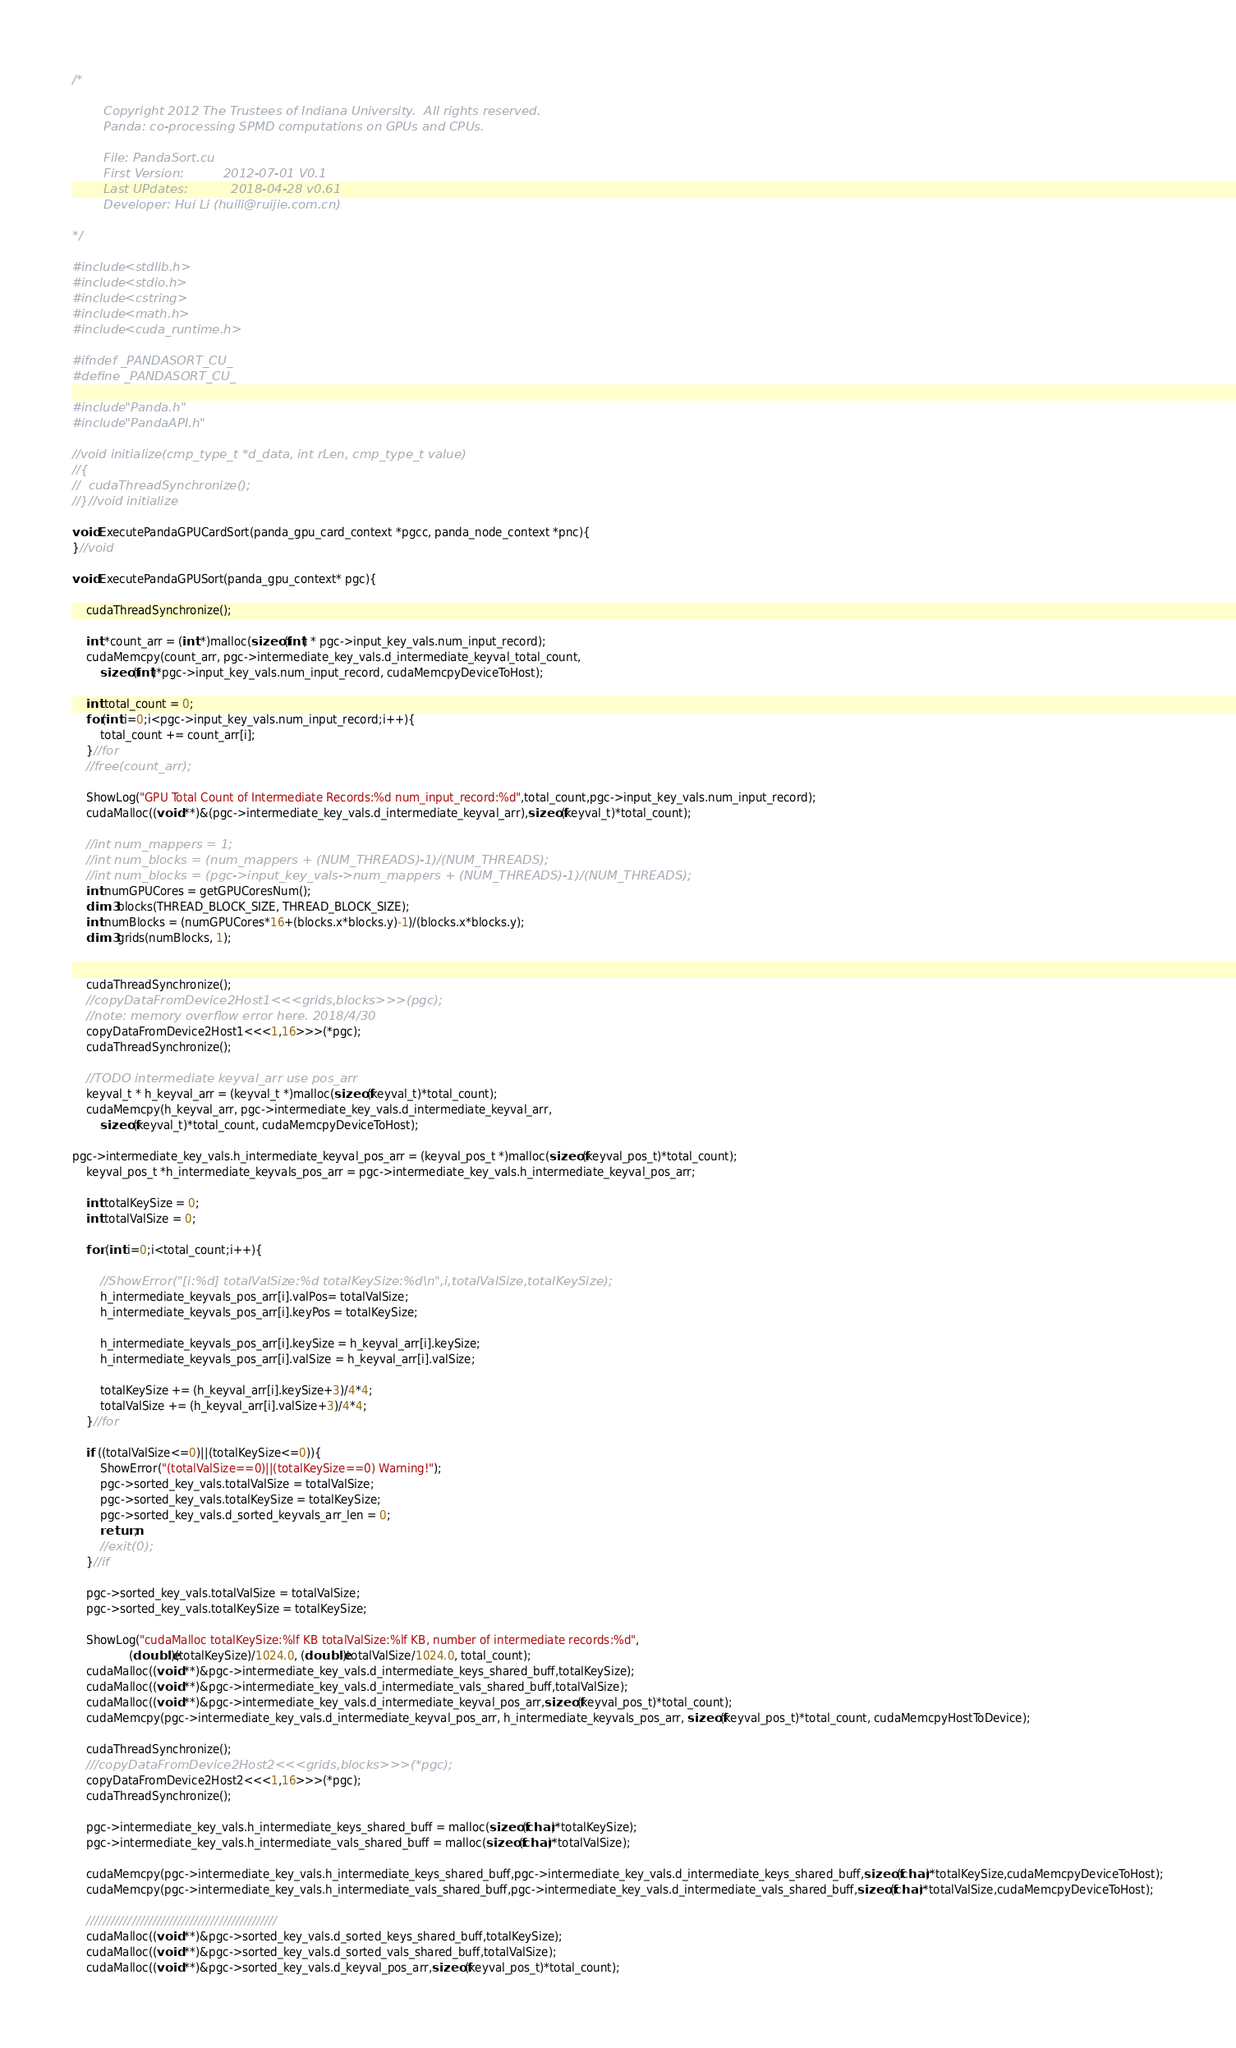<code> <loc_0><loc_0><loc_500><loc_500><_Cuda_>/*

        Copyright 2012 The Trustees of Indiana University.  All rights reserved.
        Panda: co-processing SPMD computations on GPUs and CPUs.

        File: PandaSort.cu
        First Version:          2012-07-01 V0.1
        Last UPdates:           2018-04-28 v0.61
        Developer: Hui Li (huili@ruijie.com.cn)

*/

#include <stdlib.h>
#include <stdio.h>
#include <cstring>
#include <math.h>
#include <cuda_runtime.h>

#ifndef _PANDASORT_CU_
#define _PANDASORT_CU_

#include "Panda.h"
#include "PandaAPI.h"

//void initialize(cmp_type_t *d_data, int rLen, cmp_type_t value)
//{
//	cudaThreadSynchronize();
//}//void initialize

void ExecutePandaGPUCardSort(panda_gpu_card_context *pgcc, panda_node_context *pnc){
}//void

void ExecutePandaGPUSort(panda_gpu_context* pgc){

	cudaThreadSynchronize();

	int *count_arr = (int *)malloc(sizeof(int) * pgc->input_key_vals.num_input_record);
	cudaMemcpy(count_arr, pgc->intermediate_key_vals.d_intermediate_keyval_total_count, 
		sizeof(int)*pgc->input_key_vals.num_input_record, cudaMemcpyDeviceToHost);

	int total_count = 0;
	for(int i=0;i<pgc->input_key_vals.num_input_record;i++){
		total_count += count_arr[i];
	}//for
	//free(count_arr);

	ShowLog("GPU Total Count of Intermediate Records:%d num_input_record:%d",total_count,pgc->input_key_vals.num_input_record);
	cudaMalloc((void **)&(pgc->intermediate_key_vals.d_intermediate_keyval_arr),sizeof(keyval_t)*total_count);

	//int num_mappers = 1;
	//int num_blocks = (num_mappers + (NUM_THREADS)-1)/(NUM_THREADS);
	//int num_blocks = (pgc->input_key_vals->num_mappers + (NUM_THREADS)-1)/(NUM_THREADS);
	int numGPUCores = getGPUCoresNum();
	dim3 blocks(THREAD_BLOCK_SIZE, THREAD_BLOCK_SIZE);
	int numBlocks = (numGPUCores*16+(blocks.x*blocks.y)-1)/(blocks.x*blocks.y);
	dim3 grids(numBlocks, 1);


	cudaThreadSynchronize();
	//copyDataFromDevice2Host1<<<grids,blocks>>>(pgc);
	//note: memory overflow error here. 2018/4/30
	copyDataFromDevice2Host1<<<1,16>>>(*pgc);
	cudaThreadSynchronize();

	//TODO intermediate keyval_arr use pos_arr
	keyval_t * h_keyval_arr = (keyval_t *)malloc(sizeof(keyval_t)*total_count);
	cudaMemcpy(h_keyval_arr, pgc->intermediate_key_vals.d_intermediate_keyval_arr, 
		sizeof(keyval_t)*total_count, cudaMemcpyDeviceToHost);

pgc->intermediate_key_vals.h_intermediate_keyval_pos_arr = (keyval_pos_t *)malloc(sizeof(keyval_pos_t)*total_count);
	keyval_pos_t *h_intermediate_keyvals_pos_arr = pgc->intermediate_key_vals.h_intermediate_keyval_pos_arr;

	int totalKeySize = 0;
	int totalValSize = 0;

	for (int i=0;i<total_count;i++){

		//ShowError("[i:%d] totalValSize:%d totalKeySize:%d\n",i,totalValSize,totalKeySize);
		h_intermediate_keyvals_pos_arr[i].valPos= totalValSize;
		h_intermediate_keyvals_pos_arr[i].keyPos = totalKeySize;

		h_intermediate_keyvals_pos_arr[i].keySize = h_keyval_arr[i].keySize;
		h_intermediate_keyvals_pos_arr[i].valSize = h_keyval_arr[i].valSize;

		totalKeySize += (h_keyval_arr[i].keySize+3)/4*4;
		totalValSize += (h_keyval_arr[i].valSize+3)/4*4;
	}//for

	if ((totalValSize<=0)||(totalKeySize<=0)){
		ShowError("(totalValSize==0)||(totalKeySize==0) Warning!");
		pgc->sorted_key_vals.totalValSize = totalValSize;
		pgc->sorted_key_vals.totalKeySize = totalKeySize;
		pgc->sorted_key_vals.d_sorted_keyvals_arr_len = 0;
		return;	
		//exit(0);
	}//if

	pgc->sorted_key_vals.totalValSize = totalValSize;
	pgc->sorted_key_vals.totalKeySize = totalKeySize;

	ShowLog("cudaMalloc totalKeySize:%lf KB totalValSize:%lf KB, number of intermediate records:%d", 
				(double)(totalKeySize)/1024.0, (double)totalValSize/1024.0, total_count);
	cudaMalloc((void **)&pgc->intermediate_key_vals.d_intermediate_keys_shared_buff,totalKeySize);
	cudaMalloc((void **)&pgc->intermediate_key_vals.d_intermediate_vals_shared_buff,totalValSize);
	cudaMalloc((void **)&pgc->intermediate_key_vals.d_intermediate_keyval_pos_arr,sizeof(keyval_pos_t)*total_count);
	cudaMemcpy(pgc->intermediate_key_vals.d_intermediate_keyval_pos_arr, h_intermediate_keyvals_pos_arr, sizeof(keyval_pos_t)*total_count, cudaMemcpyHostToDevice);

	cudaThreadSynchronize();
	///copyDataFromDevice2Host2<<<grids,blocks>>>(*pgc);
	copyDataFromDevice2Host2<<<1,16>>>(*pgc);
	cudaThreadSynchronize();

	pgc->intermediate_key_vals.h_intermediate_keys_shared_buff = malloc(sizeof(char)*totalKeySize);
	pgc->intermediate_key_vals.h_intermediate_vals_shared_buff = malloc(sizeof(char)*totalValSize);

	cudaMemcpy(pgc->intermediate_key_vals.h_intermediate_keys_shared_buff,pgc->intermediate_key_vals.d_intermediate_keys_shared_buff,sizeof(char)*totalKeySize,cudaMemcpyDeviceToHost);
	cudaMemcpy(pgc->intermediate_key_vals.h_intermediate_vals_shared_buff,pgc->intermediate_key_vals.d_intermediate_vals_shared_buff,sizeof(char)*totalValSize,cudaMemcpyDeviceToHost);

	//////////////////////////////////////////////
	cudaMalloc((void **)&pgc->sorted_key_vals.d_sorted_keys_shared_buff,totalKeySize);
	cudaMalloc((void **)&pgc->sorted_key_vals.d_sorted_vals_shared_buff,totalValSize);
	cudaMalloc((void **)&pgc->sorted_key_vals.d_keyval_pos_arr,sizeof(keyval_pos_t)*total_count);
</code> 